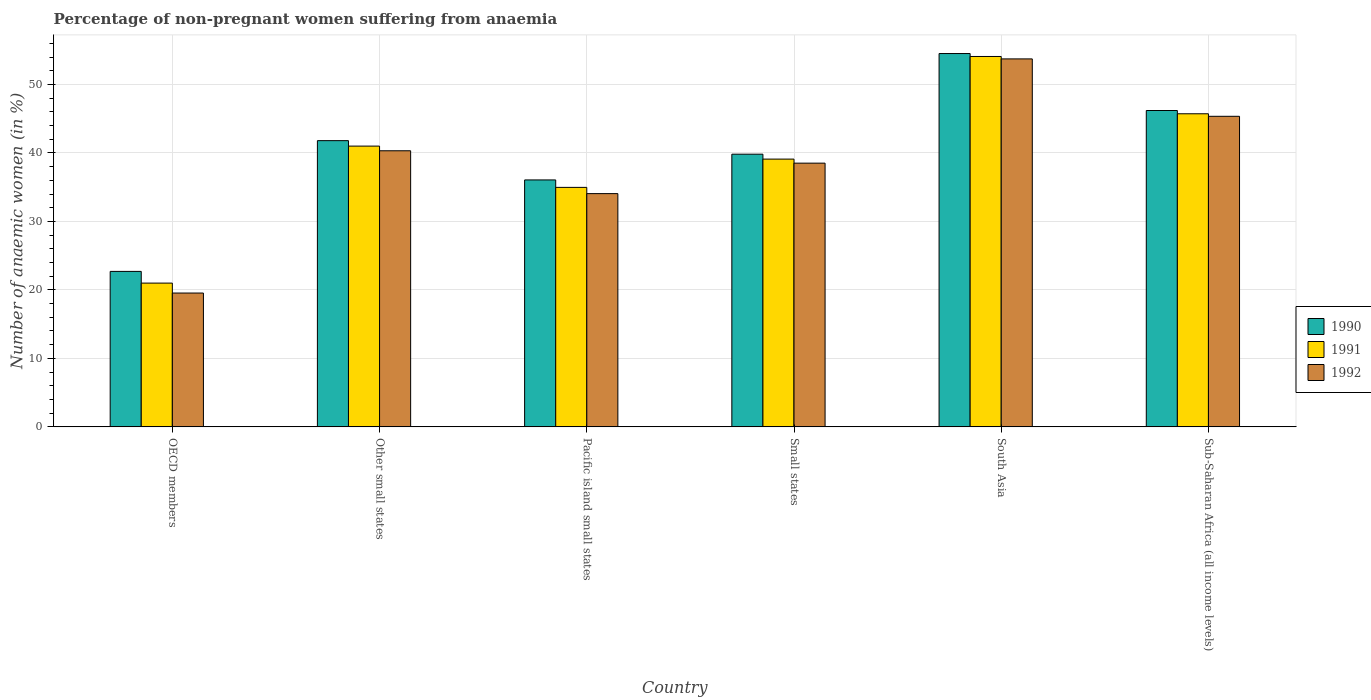Are the number of bars per tick equal to the number of legend labels?
Your response must be concise. Yes. Are the number of bars on each tick of the X-axis equal?
Give a very brief answer. Yes. How many bars are there on the 4th tick from the right?
Keep it short and to the point. 3. In how many cases, is the number of bars for a given country not equal to the number of legend labels?
Make the answer very short. 0. What is the percentage of non-pregnant women suffering from anaemia in 1992 in Small states?
Your answer should be compact. 38.51. Across all countries, what is the maximum percentage of non-pregnant women suffering from anaemia in 1992?
Your answer should be compact. 53.73. Across all countries, what is the minimum percentage of non-pregnant women suffering from anaemia in 1990?
Offer a very short reply. 22.7. In which country was the percentage of non-pregnant women suffering from anaemia in 1991 maximum?
Provide a short and direct response. South Asia. What is the total percentage of non-pregnant women suffering from anaemia in 1991 in the graph?
Provide a short and direct response. 235.84. What is the difference between the percentage of non-pregnant women suffering from anaemia in 1991 in OECD members and that in South Asia?
Your answer should be compact. -33.09. What is the difference between the percentage of non-pregnant women suffering from anaemia in 1990 in OECD members and the percentage of non-pregnant women suffering from anaemia in 1991 in Other small states?
Make the answer very short. -18.3. What is the average percentage of non-pregnant women suffering from anaemia in 1991 per country?
Your response must be concise. 39.31. What is the difference between the percentage of non-pregnant women suffering from anaemia of/in 1992 and percentage of non-pregnant women suffering from anaemia of/in 1990 in South Asia?
Your response must be concise. -0.78. In how many countries, is the percentage of non-pregnant women suffering from anaemia in 1992 greater than 10 %?
Ensure brevity in your answer.  6. What is the ratio of the percentage of non-pregnant women suffering from anaemia in 1991 in Pacific island small states to that in South Asia?
Provide a short and direct response. 0.65. What is the difference between the highest and the second highest percentage of non-pregnant women suffering from anaemia in 1992?
Provide a short and direct response. -5.03. What is the difference between the highest and the lowest percentage of non-pregnant women suffering from anaemia in 1990?
Give a very brief answer. 31.81. In how many countries, is the percentage of non-pregnant women suffering from anaemia in 1992 greater than the average percentage of non-pregnant women suffering from anaemia in 1992 taken over all countries?
Your answer should be compact. 3. Is the sum of the percentage of non-pregnant women suffering from anaemia in 1991 in Pacific island small states and South Asia greater than the maximum percentage of non-pregnant women suffering from anaemia in 1990 across all countries?
Provide a succinct answer. Yes. Are all the bars in the graph horizontal?
Provide a succinct answer. No. What is the difference between two consecutive major ticks on the Y-axis?
Offer a very short reply. 10. Are the values on the major ticks of Y-axis written in scientific E-notation?
Keep it short and to the point. No. Where does the legend appear in the graph?
Your answer should be very brief. Center right. How many legend labels are there?
Your response must be concise. 3. How are the legend labels stacked?
Provide a short and direct response. Vertical. What is the title of the graph?
Give a very brief answer. Percentage of non-pregnant women suffering from anaemia. What is the label or title of the Y-axis?
Your answer should be compact. Number of anaemic women (in %). What is the Number of anaemic women (in %) in 1990 in OECD members?
Your answer should be compact. 22.7. What is the Number of anaemic women (in %) in 1991 in OECD members?
Ensure brevity in your answer.  20.99. What is the Number of anaemic women (in %) of 1992 in OECD members?
Keep it short and to the point. 19.54. What is the Number of anaemic women (in %) in 1990 in Other small states?
Your response must be concise. 41.79. What is the Number of anaemic women (in %) in 1991 in Other small states?
Your answer should be compact. 40.99. What is the Number of anaemic women (in %) in 1992 in Other small states?
Offer a very short reply. 40.31. What is the Number of anaemic women (in %) of 1990 in Pacific island small states?
Keep it short and to the point. 36.06. What is the Number of anaemic women (in %) of 1991 in Pacific island small states?
Your answer should be very brief. 34.97. What is the Number of anaemic women (in %) in 1992 in Pacific island small states?
Offer a terse response. 34.06. What is the Number of anaemic women (in %) in 1990 in Small states?
Ensure brevity in your answer.  39.82. What is the Number of anaemic women (in %) of 1991 in Small states?
Your answer should be compact. 39.1. What is the Number of anaemic women (in %) of 1992 in Small states?
Your answer should be very brief. 38.51. What is the Number of anaemic women (in %) in 1990 in South Asia?
Provide a succinct answer. 54.51. What is the Number of anaemic women (in %) in 1991 in South Asia?
Offer a terse response. 54.08. What is the Number of anaemic women (in %) in 1992 in South Asia?
Your response must be concise. 53.73. What is the Number of anaemic women (in %) of 1990 in Sub-Saharan Africa (all income levels)?
Keep it short and to the point. 46.19. What is the Number of anaemic women (in %) in 1991 in Sub-Saharan Africa (all income levels)?
Provide a succinct answer. 45.71. What is the Number of anaemic women (in %) in 1992 in Sub-Saharan Africa (all income levels)?
Give a very brief answer. 45.34. Across all countries, what is the maximum Number of anaemic women (in %) in 1990?
Give a very brief answer. 54.51. Across all countries, what is the maximum Number of anaemic women (in %) of 1991?
Provide a short and direct response. 54.08. Across all countries, what is the maximum Number of anaemic women (in %) in 1992?
Offer a terse response. 53.73. Across all countries, what is the minimum Number of anaemic women (in %) of 1990?
Provide a short and direct response. 22.7. Across all countries, what is the minimum Number of anaemic women (in %) in 1991?
Give a very brief answer. 20.99. Across all countries, what is the minimum Number of anaemic women (in %) of 1992?
Ensure brevity in your answer.  19.54. What is the total Number of anaemic women (in %) of 1990 in the graph?
Provide a succinct answer. 241.06. What is the total Number of anaemic women (in %) in 1991 in the graph?
Provide a short and direct response. 235.84. What is the total Number of anaemic women (in %) of 1992 in the graph?
Provide a short and direct response. 231.49. What is the difference between the Number of anaemic women (in %) in 1990 in OECD members and that in Other small states?
Ensure brevity in your answer.  -19.09. What is the difference between the Number of anaemic women (in %) of 1991 in OECD members and that in Other small states?
Keep it short and to the point. -20. What is the difference between the Number of anaemic women (in %) of 1992 in OECD members and that in Other small states?
Ensure brevity in your answer.  -20.77. What is the difference between the Number of anaemic women (in %) of 1990 in OECD members and that in Pacific island small states?
Your answer should be very brief. -13.36. What is the difference between the Number of anaemic women (in %) in 1991 in OECD members and that in Pacific island small states?
Your answer should be compact. -13.97. What is the difference between the Number of anaemic women (in %) in 1992 in OECD members and that in Pacific island small states?
Offer a terse response. -14.52. What is the difference between the Number of anaemic women (in %) of 1990 in OECD members and that in Small states?
Offer a very short reply. -17.12. What is the difference between the Number of anaemic women (in %) of 1991 in OECD members and that in Small states?
Your answer should be compact. -18.1. What is the difference between the Number of anaemic women (in %) of 1992 in OECD members and that in Small states?
Your answer should be compact. -18.96. What is the difference between the Number of anaemic women (in %) of 1990 in OECD members and that in South Asia?
Offer a very short reply. -31.81. What is the difference between the Number of anaemic women (in %) in 1991 in OECD members and that in South Asia?
Provide a short and direct response. -33.09. What is the difference between the Number of anaemic women (in %) in 1992 in OECD members and that in South Asia?
Ensure brevity in your answer.  -34.18. What is the difference between the Number of anaemic women (in %) of 1990 in OECD members and that in Sub-Saharan Africa (all income levels)?
Ensure brevity in your answer.  -23.49. What is the difference between the Number of anaemic women (in %) of 1991 in OECD members and that in Sub-Saharan Africa (all income levels)?
Offer a very short reply. -24.72. What is the difference between the Number of anaemic women (in %) of 1992 in OECD members and that in Sub-Saharan Africa (all income levels)?
Provide a short and direct response. -25.8. What is the difference between the Number of anaemic women (in %) of 1990 in Other small states and that in Pacific island small states?
Provide a succinct answer. 5.74. What is the difference between the Number of anaemic women (in %) of 1991 in Other small states and that in Pacific island small states?
Ensure brevity in your answer.  6.03. What is the difference between the Number of anaemic women (in %) of 1992 in Other small states and that in Pacific island small states?
Your answer should be very brief. 6.26. What is the difference between the Number of anaemic women (in %) of 1990 in Other small states and that in Small states?
Your answer should be compact. 1.98. What is the difference between the Number of anaemic women (in %) of 1991 in Other small states and that in Small states?
Give a very brief answer. 1.9. What is the difference between the Number of anaemic women (in %) in 1992 in Other small states and that in Small states?
Give a very brief answer. 1.81. What is the difference between the Number of anaemic women (in %) in 1990 in Other small states and that in South Asia?
Make the answer very short. -12.72. What is the difference between the Number of anaemic women (in %) of 1991 in Other small states and that in South Asia?
Provide a succinct answer. -13.09. What is the difference between the Number of anaemic women (in %) of 1992 in Other small states and that in South Asia?
Your answer should be very brief. -13.41. What is the difference between the Number of anaemic women (in %) in 1990 in Other small states and that in Sub-Saharan Africa (all income levels)?
Offer a very short reply. -4.4. What is the difference between the Number of anaemic women (in %) of 1991 in Other small states and that in Sub-Saharan Africa (all income levels)?
Your response must be concise. -4.72. What is the difference between the Number of anaemic women (in %) of 1992 in Other small states and that in Sub-Saharan Africa (all income levels)?
Provide a succinct answer. -5.03. What is the difference between the Number of anaemic women (in %) of 1990 in Pacific island small states and that in Small states?
Ensure brevity in your answer.  -3.76. What is the difference between the Number of anaemic women (in %) of 1991 in Pacific island small states and that in Small states?
Make the answer very short. -4.13. What is the difference between the Number of anaemic women (in %) in 1992 in Pacific island small states and that in Small states?
Offer a very short reply. -4.45. What is the difference between the Number of anaemic women (in %) in 1990 in Pacific island small states and that in South Asia?
Keep it short and to the point. -18.45. What is the difference between the Number of anaemic women (in %) in 1991 in Pacific island small states and that in South Asia?
Your response must be concise. -19.11. What is the difference between the Number of anaemic women (in %) in 1992 in Pacific island small states and that in South Asia?
Ensure brevity in your answer.  -19.67. What is the difference between the Number of anaemic women (in %) of 1990 in Pacific island small states and that in Sub-Saharan Africa (all income levels)?
Your answer should be very brief. -10.14. What is the difference between the Number of anaemic women (in %) in 1991 in Pacific island small states and that in Sub-Saharan Africa (all income levels)?
Provide a short and direct response. -10.75. What is the difference between the Number of anaemic women (in %) of 1992 in Pacific island small states and that in Sub-Saharan Africa (all income levels)?
Offer a very short reply. -11.29. What is the difference between the Number of anaemic women (in %) of 1990 in Small states and that in South Asia?
Make the answer very short. -14.69. What is the difference between the Number of anaemic women (in %) in 1991 in Small states and that in South Asia?
Offer a very short reply. -14.98. What is the difference between the Number of anaemic women (in %) of 1992 in Small states and that in South Asia?
Provide a succinct answer. -15.22. What is the difference between the Number of anaemic women (in %) in 1990 in Small states and that in Sub-Saharan Africa (all income levels)?
Give a very brief answer. -6.38. What is the difference between the Number of anaemic women (in %) in 1991 in Small states and that in Sub-Saharan Africa (all income levels)?
Provide a succinct answer. -6.62. What is the difference between the Number of anaemic women (in %) in 1992 in Small states and that in Sub-Saharan Africa (all income levels)?
Your response must be concise. -6.84. What is the difference between the Number of anaemic women (in %) of 1990 in South Asia and that in Sub-Saharan Africa (all income levels)?
Offer a very short reply. 8.32. What is the difference between the Number of anaemic women (in %) in 1991 in South Asia and that in Sub-Saharan Africa (all income levels)?
Your answer should be very brief. 8.37. What is the difference between the Number of anaemic women (in %) of 1992 in South Asia and that in Sub-Saharan Africa (all income levels)?
Your response must be concise. 8.38. What is the difference between the Number of anaemic women (in %) in 1990 in OECD members and the Number of anaemic women (in %) in 1991 in Other small states?
Ensure brevity in your answer.  -18.3. What is the difference between the Number of anaemic women (in %) of 1990 in OECD members and the Number of anaemic women (in %) of 1992 in Other small states?
Keep it short and to the point. -17.61. What is the difference between the Number of anaemic women (in %) of 1991 in OECD members and the Number of anaemic women (in %) of 1992 in Other small states?
Offer a very short reply. -19.32. What is the difference between the Number of anaemic women (in %) in 1990 in OECD members and the Number of anaemic women (in %) in 1991 in Pacific island small states?
Give a very brief answer. -12.27. What is the difference between the Number of anaemic women (in %) in 1990 in OECD members and the Number of anaemic women (in %) in 1992 in Pacific island small states?
Offer a very short reply. -11.36. What is the difference between the Number of anaemic women (in %) of 1991 in OECD members and the Number of anaemic women (in %) of 1992 in Pacific island small states?
Your answer should be very brief. -13.06. What is the difference between the Number of anaemic women (in %) of 1990 in OECD members and the Number of anaemic women (in %) of 1991 in Small states?
Your answer should be compact. -16.4. What is the difference between the Number of anaemic women (in %) of 1990 in OECD members and the Number of anaemic women (in %) of 1992 in Small states?
Make the answer very short. -15.81. What is the difference between the Number of anaemic women (in %) in 1991 in OECD members and the Number of anaemic women (in %) in 1992 in Small states?
Your response must be concise. -17.51. What is the difference between the Number of anaemic women (in %) in 1990 in OECD members and the Number of anaemic women (in %) in 1991 in South Asia?
Give a very brief answer. -31.38. What is the difference between the Number of anaemic women (in %) of 1990 in OECD members and the Number of anaemic women (in %) of 1992 in South Asia?
Provide a succinct answer. -31.03. What is the difference between the Number of anaemic women (in %) in 1991 in OECD members and the Number of anaemic women (in %) in 1992 in South Asia?
Make the answer very short. -32.73. What is the difference between the Number of anaemic women (in %) of 1990 in OECD members and the Number of anaemic women (in %) of 1991 in Sub-Saharan Africa (all income levels)?
Provide a short and direct response. -23.01. What is the difference between the Number of anaemic women (in %) in 1990 in OECD members and the Number of anaemic women (in %) in 1992 in Sub-Saharan Africa (all income levels)?
Your answer should be very brief. -22.65. What is the difference between the Number of anaemic women (in %) in 1991 in OECD members and the Number of anaemic women (in %) in 1992 in Sub-Saharan Africa (all income levels)?
Your answer should be compact. -24.35. What is the difference between the Number of anaemic women (in %) of 1990 in Other small states and the Number of anaemic women (in %) of 1991 in Pacific island small states?
Provide a short and direct response. 6.82. What is the difference between the Number of anaemic women (in %) in 1990 in Other small states and the Number of anaemic women (in %) in 1992 in Pacific island small states?
Ensure brevity in your answer.  7.73. What is the difference between the Number of anaemic women (in %) in 1991 in Other small states and the Number of anaemic women (in %) in 1992 in Pacific island small states?
Ensure brevity in your answer.  6.94. What is the difference between the Number of anaemic women (in %) of 1990 in Other small states and the Number of anaemic women (in %) of 1991 in Small states?
Provide a short and direct response. 2.7. What is the difference between the Number of anaemic women (in %) in 1990 in Other small states and the Number of anaemic women (in %) in 1992 in Small states?
Offer a very short reply. 3.29. What is the difference between the Number of anaemic women (in %) in 1991 in Other small states and the Number of anaemic women (in %) in 1992 in Small states?
Your answer should be compact. 2.49. What is the difference between the Number of anaemic women (in %) in 1990 in Other small states and the Number of anaemic women (in %) in 1991 in South Asia?
Offer a very short reply. -12.29. What is the difference between the Number of anaemic women (in %) in 1990 in Other small states and the Number of anaemic women (in %) in 1992 in South Asia?
Ensure brevity in your answer.  -11.93. What is the difference between the Number of anaemic women (in %) in 1991 in Other small states and the Number of anaemic women (in %) in 1992 in South Asia?
Make the answer very short. -12.73. What is the difference between the Number of anaemic women (in %) in 1990 in Other small states and the Number of anaemic women (in %) in 1991 in Sub-Saharan Africa (all income levels)?
Offer a terse response. -3.92. What is the difference between the Number of anaemic women (in %) in 1990 in Other small states and the Number of anaemic women (in %) in 1992 in Sub-Saharan Africa (all income levels)?
Keep it short and to the point. -3.55. What is the difference between the Number of anaemic women (in %) of 1991 in Other small states and the Number of anaemic women (in %) of 1992 in Sub-Saharan Africa (all income levels)?
Ensure brevity in your answer.  -4.35. What is the difference between the Number of anaemic women (in %) of 1990 in Pacific island small states and the Number of anaemic women (in %) of 1991 in Small states?
Your response must be concise. -3.04. What is the difference between the Number of anaemic women (in %) in 1990 in Pacific island small states and the Number of anaemic women (in %) in 1992 in Small states?
Your answer should be very brief. -2.45. What is the difference between the Number of anaemic women (in %) in 1991 in Pacific island small states and the Number of anaemic women (in %) in 1992 in Small states?
Keep it short and to the point. -3.54. What is the difference between the Number of anaemic women (in %) of 1990 in Pacific island small states and the Number of anaemic women (in %) of 1991 in South Asia?
Offer a terse response. -18.02. What is the difference between the Number of anaemic women (in %) of 1990 in Pacific island small states and the Number of anaemic women (in %) of 1992 in South Asia?
Ensure brevity in your answer.  -17.67. What is the difference between the Number of anaemic women (in %) of 1991 in Pacific island small states and the Number of anaemic women (in %) of 1992 in South Asia?
Your answer should be compact. -18.76. What is the difference between the Number of anaemic women (in %) in 1990 in Pacific island small states and the Number of anaemic women (in %) in 1991 in Sub-Saharan Africa (all income levels)?
Give a very brief answer. -9.66. What is the difference between the Number of anaemic women (in %) of 1990 in Pacific island small states and the Number of anaemic women (in %) of 1992 in Sub-Saharan Africa (all income levels)?
Your response must be concise. -9.29. What is the difference between the Number of anaemic women (in %) of 1991 in Pacific island small states and the Number of anaemic women (in %) of 1992 in Sub-Saharan Africa (all income levels)?
Offer a very short reply. -10.38. What is the difference between the Number of anaemic women (in %) of 1990 in Small states and the Number of anaemic women (in %) of 1991 in South Asia?
Your answer should be compact. -14.26. What is the difference between the Number of anaemic women (in %) of 1990 in Small states and the Number of anaemic women (in %) of 1992 in South Asia?
Your answer should be very brief. -13.91. What is the difference between the Number of anaemic women (in %) of 1991 in Small states and the Number of anaemic women (in %) of 1992 in South Asia?
Your answer should be compact. -14.63. What is the difference between the Number of anaemic women (in %) of 1990 in Small states and the Number of anaemic women (in %) of 1991 in Sub-Saharan Africa (all income levels)?
Keep it short and to the point. -5.9. What is the difference between the Number of anaemic women (in %) in 1990 in Small states and the Number of anaemic women (in %) in 1992 in Sub-Saharan Africa (all income levels)?
Your answer should be compact. -5.53. What is the difference between the Number of anaemic women (in %) in 1991 in Small states and the Number of anaemic women (in %) in 1992 in Sub-Saharan Africa (all income levels)?
Give a very brief answer. -6.25. What is the difference between the Number of anaemic women (in %) in 1990 in South Asia and the Number of anaemic women (in %) in 1991 in Sub-Saharan Africa (all income levels)?
Offer a very short reply. 8.8. What is the difference between the Number of anaemic women (in %) of 1990 in South Asia and the Number of anaemic women (in %) of 1992 in Sub-Saharan Africa (all income levels)?
Offer a very short reply. 9.16. What is the difference between the Number of anaemic women (in %) in 1991 in South Asia and the Number of anaemic women (in %) in 1992 in Sub-Saharan Africa (all income levels)?
Keep it short and to the point. 8.74. What is the average Number of anaemic women (in %) in 1990 per country?
Provide a short and direct response. 40.18. What is the average Number of anaemic women (in %) in 1991 per country?
Provide a succinct answer. 39.31. What is the average Number of anaemic women (in %) of 1992 per country?
Your answer should be compact. 38.58. What is the difference between the Number of anaemic women (in %) in 1990 and Number of anaemic women (in %) in 1991 in OECD members?
Ensure brevity in your answer.  1.71. What is the difference between the Number of anaemic women (in %) in 1990 and Number of anaemic women (in %) in 1992 in OECD members?
Provide a short and direct response. 3.16. What is the difference between the Number of anaemic women (in %) in 1991 and Number of anaemic women (in %) in 1992 in OECD members?
Keep it short and to the point. 1.45. What is the difference between the Number of anaemic women (in %) in 1990 and Number of anaemic women (in %) in 1991 in Other small states?
Provide a short and direct response. 0.8. What is the difference between the Number of anaemic women (in %) of 1990 and Number of anaemic women (in %) of 1992 in Other small states?
Your answer should be compact. 1.48. What is the difference between the Number of anaemic women (in %) in 1991 and Number of anaemic women (in %) in 1992 in Other small states?
Your answer should be very brief. 0.68. What is the difference between the Number of anaemic women (in %) in 1990 and Number of anaemic women (in %) in 1991 in Pacific island small states?
Ensure brevity in your answer.  1.09. What is the difference between the Number of anaemic women (in %) in 1990 and Number of anaemic women (in %) in 1992 in Pacific island small states?
Offer a terse response. 2. What is the difference between the Number of anaemic women (in %) in 1991 and Number of anaemic women (in %) in 1992 in Pacific island small states?
Your answer should be very brief. 0.91. What is the difference between the Number of anaemic women (in %) in 1990 and Number of anaemic women (in %) in 1991 in Small states?
Offer a very short reply. 0.72. What is the difference between the Number of anaemic women (in %) of 1990 and Number of anaemic women (in %) of 1992 in Small states?
Your answer should be compact. 1.31. What is the difference between the Number of anaemic women (in %) in 1991 and Number of anaemic women (in %) in 1992 in Small states?
Keep it short and to the point. 0.59. What is the difference between the Number of anaemic women (in %) in 1990 and Number of anaemic women (in %) in 1991 in South Asia?
Give a very brief answer. 0.43. What is the difference between the Number of anaemic women (in %) of 1990 and Number of anaemic women (in %) of 1992 in South Asia?
Provide a short and direct response. 0.78. What is the difference between the Number of anaemic women (in %) in 1991 and Number of anaemic women (in %) in 1992 in South Asia?
Your response must be concise. 0.35. What is the difference between the Number of anaemic women (in %) in 1990 and Number of anaemic women (in %) in 1991 in Sub-Saharan Africa (all income levels)?
Provide a short and direct response. 0.48. What is the difference between the Number of anaemic women (in %) in 1990 and Number of anaemic women (in %) in 1992 in Sub-Saharan Africa (all income levels)?
Your answer should be compact. 0.85. What is the difference between the Number of anaemic women (in %) of 1991 and Number of anaemic women (in %) of 1992 in Sub-Saharan Africa (all income levels)?
Keep it short and to the point. 0.37. What is the ratio of the Number of anaemic women (in %) of 1990 in OECD members to that in Other small states?
Give a very brief answer. 0.54. What is the ratio of the Number of anaemic women (in %) in 1991 in OECD members to that in Other small states?
Your answer should be compact. 0.51. What is the ratio of the Number of anaemic women (in %) of 1992 in OECD members to that in Other small states?
Your response must be concise. 0.48. What is the ratio of the Number of anaemic women (in %) in 1990 in OECD members to that in Pacific island small states?
Your answer should be very brief. 0.63. What is the ratio of the Number of anaemic women (in %) of 1991 in OECD members to that in Pacific island small states?
Offer a terse response. 0.6. What is the ratio of the Number of anaemic women (in %) of 1992 in OECD members to that in Pacific island small states?
Your response must be concise. 0.57. What is the ratio of the Number of anaemic women (in %) of 1990 in OECD members to that in Small states?
Your answer should be compact. 0.57. What is the ratio of the Number of anaemic women (in %) in 1991 in OECD members to that in Small states?
Give a very brief answer. 0.54. What is the ratio of the Number of anaemic women (in %) of 1992 in OECD members to that in Small states?
Provide a short and direct response. 0.51. What is the ratio of the Number of anaemic women (in %) in 1990 in OECD members to that in South Asia?
Ensure brevity in your answer.  0.42. What is the ratio of the Number of anaemic women (in %) of 1991 in OECD members to that in South Asia?
Offer a very short reply. 0.39. What is the ratio of the Number of anaemic women (in %) in 1992 in OECD members to that in South Asia?
Your answer should be very brief. 0.36. What is the ratio of the Number of anaemic women (in %) of 1990 in OECD members to that in Sub-Saharan Africa (all income levels)?
Keep it short and to the point. 0.49. What is the ratio of the Number of anaemic women (in %) of 1991 in OECD members to that in Sub-Saharan Africa (all income levels)?
Provide a short and direct response. 0.46. What is the ratio of the Number of anaemic women (in %) in 1992 in OECD members to that in Sub-Saharan Africa (all income levels)?
Provide a succinct answer. 0.43. What is the ratio of the Number of anaemic women (in %) of 1990 in Other small states to that in Pacific island small states?
Your answer should be very brief. 1.16. What is the ratio of the Number of anaemic women (in %) of 1991 in Other small states to that in Pacific island small states?
Your response must be concise. 1.17. What is the ratio of the Number of anaemic women (in %) in 1992 in Other small states to that in Pacific island small states?
Make the answer very short. 1.18. What is the ratio of the Number of anaemic women (in %) of 1990 in Other small states to that in Small states?
Give a very brief answer. 1.05. What is the ratio of the Number of anaemic women (in %) of 1991 in Other small states to that in Small states?
Offer a very short reply. 1.05. What is the ratio of the Number of anaemic women (in %) in 1992 in Other small states to that in Small states?
Keep it short and to the point. 1.05. What is the ratio of the Number of anaemic women (in %) of 1990 in Other small states to that in South Asia?
Provide a succinct answer. 0.77. What is the ratio of the Number of anaemic women (in %) in 1991 in Other small states to that in South Asia?
Your answer should be very brief. 0.76. What is the ratio of the Number of anaemic women (in %) in 1992 in Other small states to that in South Asia?
Offer a terse response. 0.75. What is the ratio of the Number of anaemic women (in %) in 1990 in Other small states to that in Sub-Saharan Africa (all income levels)?
Give a very brief answer. 0.9. What is the ratio of the Number of anaemic women (in %) of 1991 in Other small states to that in Sub-Saharan Africa (all income levels)?
Your answer should be very brief. 0.9. What is the ratio of the Number of anaemic women (in %) in 1992 in Other small states to that in Sub-Saharan Africa (all income levels)?
Offer a terse response. 0.89. What is the ratio of the Number of anaemic women (in %) of 1990 in Pacific island small states to that in Small states?
Make the answer very short. 0.91. What is the ratio of the Number of anaemic women (in %) in 1991 in Pacific island small states to that in Small states?
Give a very brief answer. 0.89. What is the ratio of the Number of anaemic women (in %) in 1992 in Pacific island small states to that in Small states?
Your answer should be very brief. 0.88. What is the ratio of the Number of anaemic women (in %) of 1990 in Pacific island small states to that in South Asia?
Your answer should be compact. 0.66. What is the ratio of the Number of anaemic women (in %) in 1991 in Pacific island small states to that in South Asia?
Your response must be concise. 0.65. What is the ratio of the Number of anaemic women (in %) in 1992 in Pacific island small states to that in South Asia?
Keep it short and to the point. 0.63. What is the ratio of the Number of anaemic women (in %) in 1990 in Pacific island small states to that in Sub-Saharan Africa (all income levels)?
Give a very brief answer. 0.78. What is the ratio of the Number of anaemic women (in %) in 1991 in Pacific island small states to that in Sub-Saharan Africa (all income levels)?
Offer a terse response. 0.76. What is the ratio of the Number of anaemic women (in %) of 1992 in Pacific island small states to that in Sub-Saharan Africa (all income levels)?
Offer a very short reply. 0.75. What is the ratio of the Number of anaemic women (in %) of 1990 in Small states to that in South Asia?
Provide a succinct answer. 0.73. What is the ratio of the Number of anaemic women (in %) in 1991 in Small states to that in South Asia?
Keep it short and to the point. 0.72. What is the ratio of the Number of anaemic women (in %) of 1992 in Small states to that in South Asia?
Ensure brevity in your answer.  0.72. What is the ratio of the Number of anaemic women (in %) of 1990 in Small states to that in Sub-Saharan Africa (all income levels)?
Provide a short and direct response. 0.86. What is the ratio of the Number of anaemic women (in %) of 1991 in Small states to that in Sub-Saharan Africa (all income levels)?
Your answer should be compact. 0.86. What is the ratio of the Number of anaemic women (in %) of 1992 in Small states to that in Sub-Saharan Africa (all income levels)?
Ensure brevity in your answer.  0.85. What is the ratio of the Number of anaemic women (in %) of 1990 in South Asia to that in Sub-Saharan Africa (all income levels)?
Your answer should be compact. 1.18. What is the ratio of the Number of anaemic women (in %) of 1991 in South Asia to that in Sub-Saharan Africa (all income levels)?
Your response must be concise. 1.18. What is the ratio of the Number of anaemic women (in %) of 1992 in South Asia to that in Sub-Saharan Africa (all income levels)?
Ensure brevity in your answer.  1.18. What is the difference between the highest and the second highest Number of anaemic women (in %) in 1990?
Provide a succinct answer. 8.32. What is the difference between the highest and the second highest Number of anaemic women (in %) of 1991?
Offer a very short reply. 8.37. What is the difference between the highest and the second highest Number of anaemic women (in %) of 1992?
Offer a very short reply. 8.38. What is the difference between the highest and the lowest Number of anaemic women (in %) in 1990?
Your answer should be very brief. 31.81. What is the difference between the highest and the lowest Number of anaemic women (in %) of 1991?
Give a very brief answer. 33.09. What is the difference between the highest and the lowest Number of anaemic women (in %) of 1992?
Ensure brevity in your answer.  34.18. 